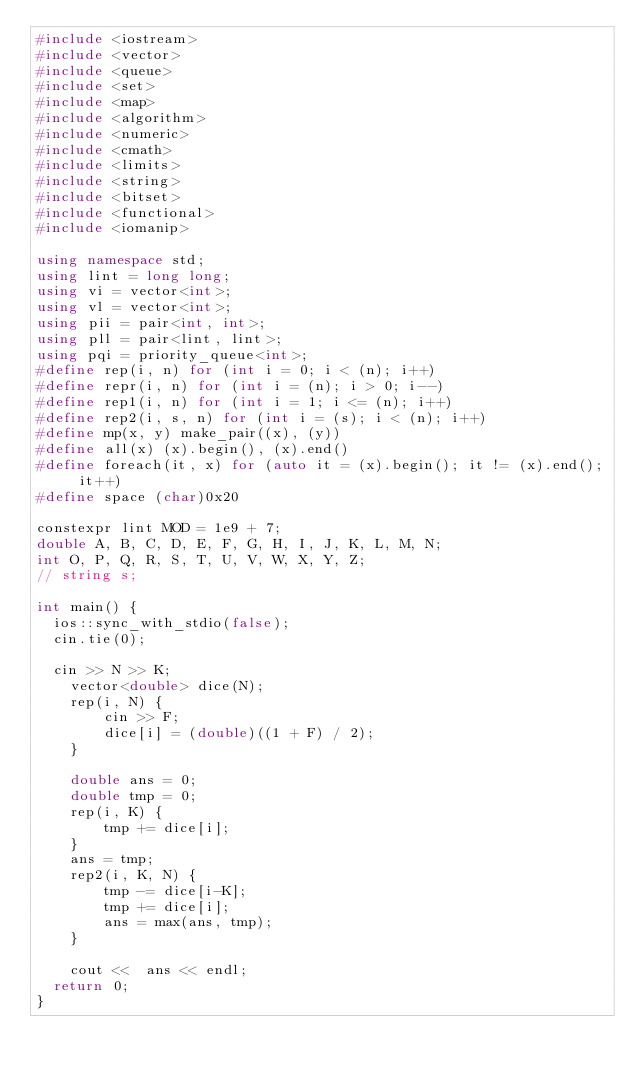Convert code to text. <code><loc_0><loc_0><loc_500><loc_500><_C++_>#include <iostream>
#include <vector>
#include <queue>
#include <set>
#include <map>
#include <algorithm>
#include <numeric>
#include <cmath>
#include <limits>
#include <string>
#include <bitset>
#include <functional>
#include <iomanip>

using namespace std;
using lint = long long;
using vi = vector<int>;
using vl = vector<int>;
using pii = pair<int, int>;
using pll = pair<lint, lint>;
using pqi = priority_queue<int>;
#define rep(i, n) for (int i = 0; i < (n); i++)
#define repr(i, n) for (int i = (n); i > 0; i--)
#define rep1(i, n) for (int i = 1; i <= (n); i++)
#define rep2(i, s, n) for (int i = (s); i < (n); i++)
#define mp(x, y) make_pair((x), (y))
#define all(x) (x).begin(), (x).end()
#define foreach(it, x) for (auto it = (x).begin(); it != (x).end(); it++)
#define space (char)0x20

constexpr lint MOD = 1e9 + 7;
double A, B, C, D, E, F, G, H, I, J, K, L, M, N;
int O, P, Q, R, S, T, U, V, W, X, Y, Z;
// string s;

int main() {
	ios::sync_with_stdio(false);
	cin.tie(0);

	cin >> N >> K;
    vector<double> dice(N);
    rep(i, N) {
        cin >> F;
        dice[i] = (double)((1 + F) / 2);
    }

    double ans = 0;
    double tmp = 0;
    rep(i, K) {
        tmp += dice[i];
    }
    ans = tmp;
    rep2(i, K, N) {
        tmp -= dice[i-K]; 
        tmp += dice[i];
        ans = max(ans, tmp);
    }

    cout <<  ans << endl;
	return 0;
}</code> 